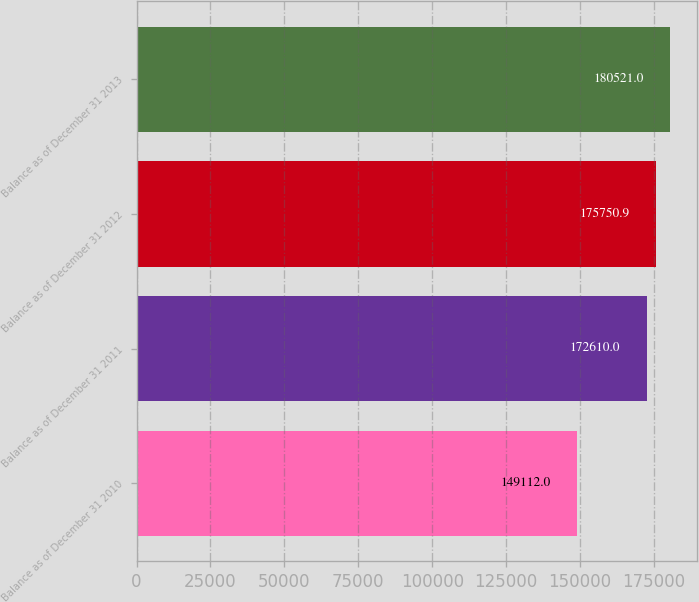Convert chart to OTSL. <chart><loc_0><loc_0><loc_500><loc_500><bar_chart><fcel>Balance as of December 31 2010<fcel>Balance as of December 31 2011<fcel>Balance as of December 31 2012<fcel>Balance as of December 31 2013<nl><fcel>149112<fcel>172610<fcel>175751<fcel>180521<nl></chart> 